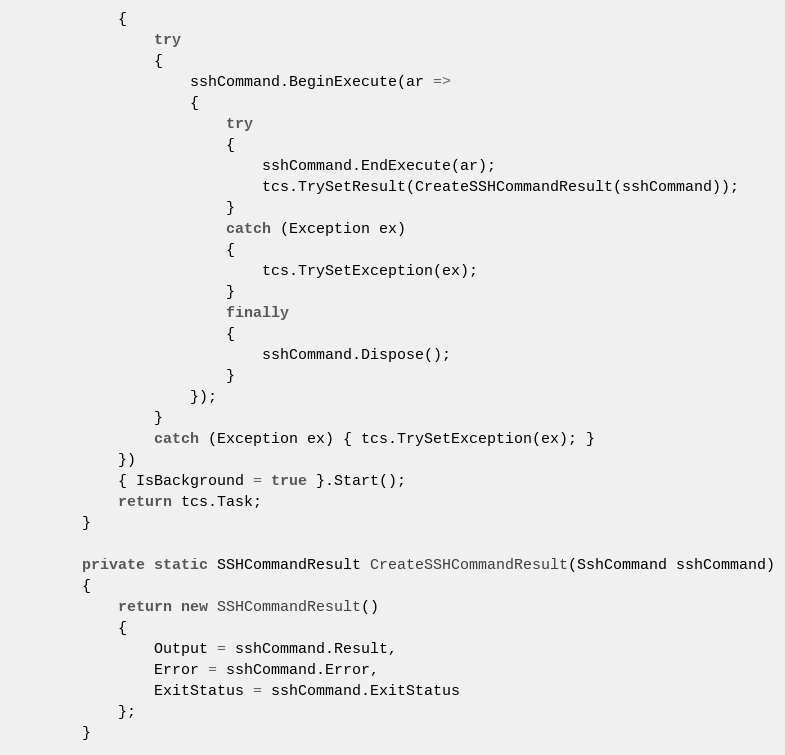Convert code to text. <code><loc_0><loc_0><loc_500><loc_500><_C#_>            {
                try
                {
                    sshCommand.BeginExecute(ar =>
                    {
                        try
                        {
                            sshCommand.EndExecute(ar);
                            tcs.TrySetResult(CreateSSHCommandResult(sshCommand));
                        }
                        catch (Exception ex)
                        {
                            tcs.TrySetException(ex);
                        }
                        finally
                        {
                            sshCommand.Dispose();
                        }
                    });
                }
                catch (Exception ex) { tcs.TrySetException(ex); }
            })
            { IsBackground = true }.Start();
            return tcs.Task;
        }

        private static SSHCommandResult CreateSSHCommandResult(SshCommand sshCommand)
        {
            return new SSHCommandResult()
            {
                Output = sshCommand.Result,
                Error = sshCommand.Error,
                ExitStatus = sshCommand.ExitStatus
            };
        }
</code> 